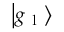<formula> <loc_0><loc_0><loc_500><loc_500>\left | g _ { l } \right ></formula> 